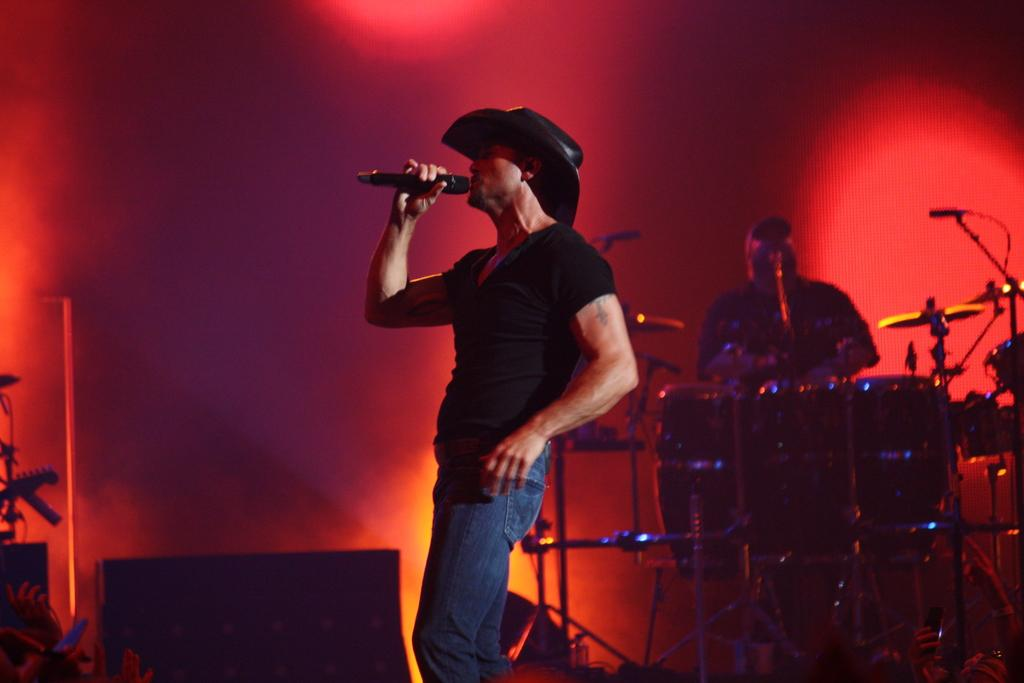What is the man in the image doing? The man is standing and holding a mic in his hand. Can you describe the second man in the image? The second man is in the background and is playing drums. What is the man with the mic likely to be doing? The man with the mic is likely to be singing or speaking into the mic. What type of attraction can be seen in the background of the image? There is no attraction visible in the background of the image; it only shows a man playing drums. 